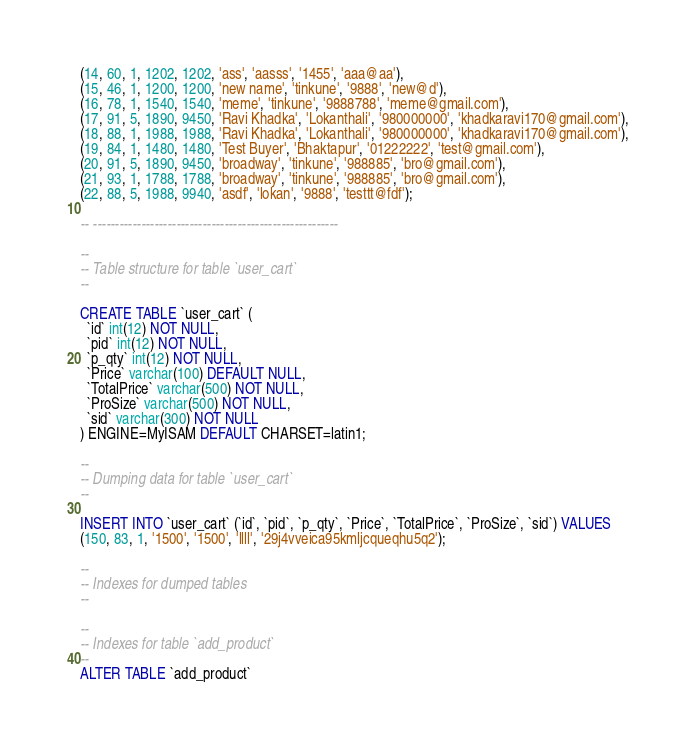Convert code to text. <code><loc_0><loc_0><loc_500><loc_500><_SQL_>(14, 60, 1, 1202, 1202, 'ass', 'aasss', '1455', 'aaa@aa'),
(15, 46, 1, 1200, 1200, 'new name', 'tinkune', '9888', 'new@d'),
(16, 78, 1, 1540, 1540, 'meme', 'tinkune', '9888788', 'meme@gmail.com'),
(17, 91, 5, 1890, 9450, 'Ravi Khadka', 'Lokanthali', '980000000', 'khadkaravi170@gmail.com'),
(18, 88, 1, 1988, 1988, 'Ravi Khadka', 'Lokanthali', '980000000', 'khadkaravi170@gmail.com'),
(19, 84, 1, 1480, 1480, 'Test Buyer', 'Bhaktapur', '01222222', 'test@gmail.com'),
(20, 91, 5, 1890, 9450, 'broadway', 'tinkune', '988885', 'bro@gmail.com'),
(21, 93, 1, 1788, 1788, 'broadway', 'tinkune', '988885', 'bro@gmail.com'),
(22, 88, 5, 1988, 9940, 'asdf', 'lokan', '9888', 'testtt@fdf');

-- --------------------------------------------------------

--
-- Table structure for table `user_cart`
--

CREATE TABLE `user_cart` (
  `id` int(12) NOT NULL,
  `pid` int(12) NOT NULL,
  `p_qty` int(12) NOT NULL,
  `Price` varchar(100) DEFAULT NULL,
  `TotalPrice` varchar(500) NOT NULL,
  `ProSize` varchar(500) NOT NULL,
  `sid` varchar(300) NOT NULL
) ENGINE=MyISAM DEFAULT CHARSET=latin1;

--
-- Dumping data for table `user_cart`
--

INSERT INTO `user_cart` (`id`, `pid`, `p_qty`, `Price`, `TotalPrice`, `ProSize`, `sid`) VALUES
(150, 83, 1, '1500', '1500', 'llll', '29j4vveica95kmljcqueqhu5q2');

--
-- Indexes for dumped tables
--

--
-- Indexes for table `add_product`
--
ALTER TABLE `add_product`</code> 